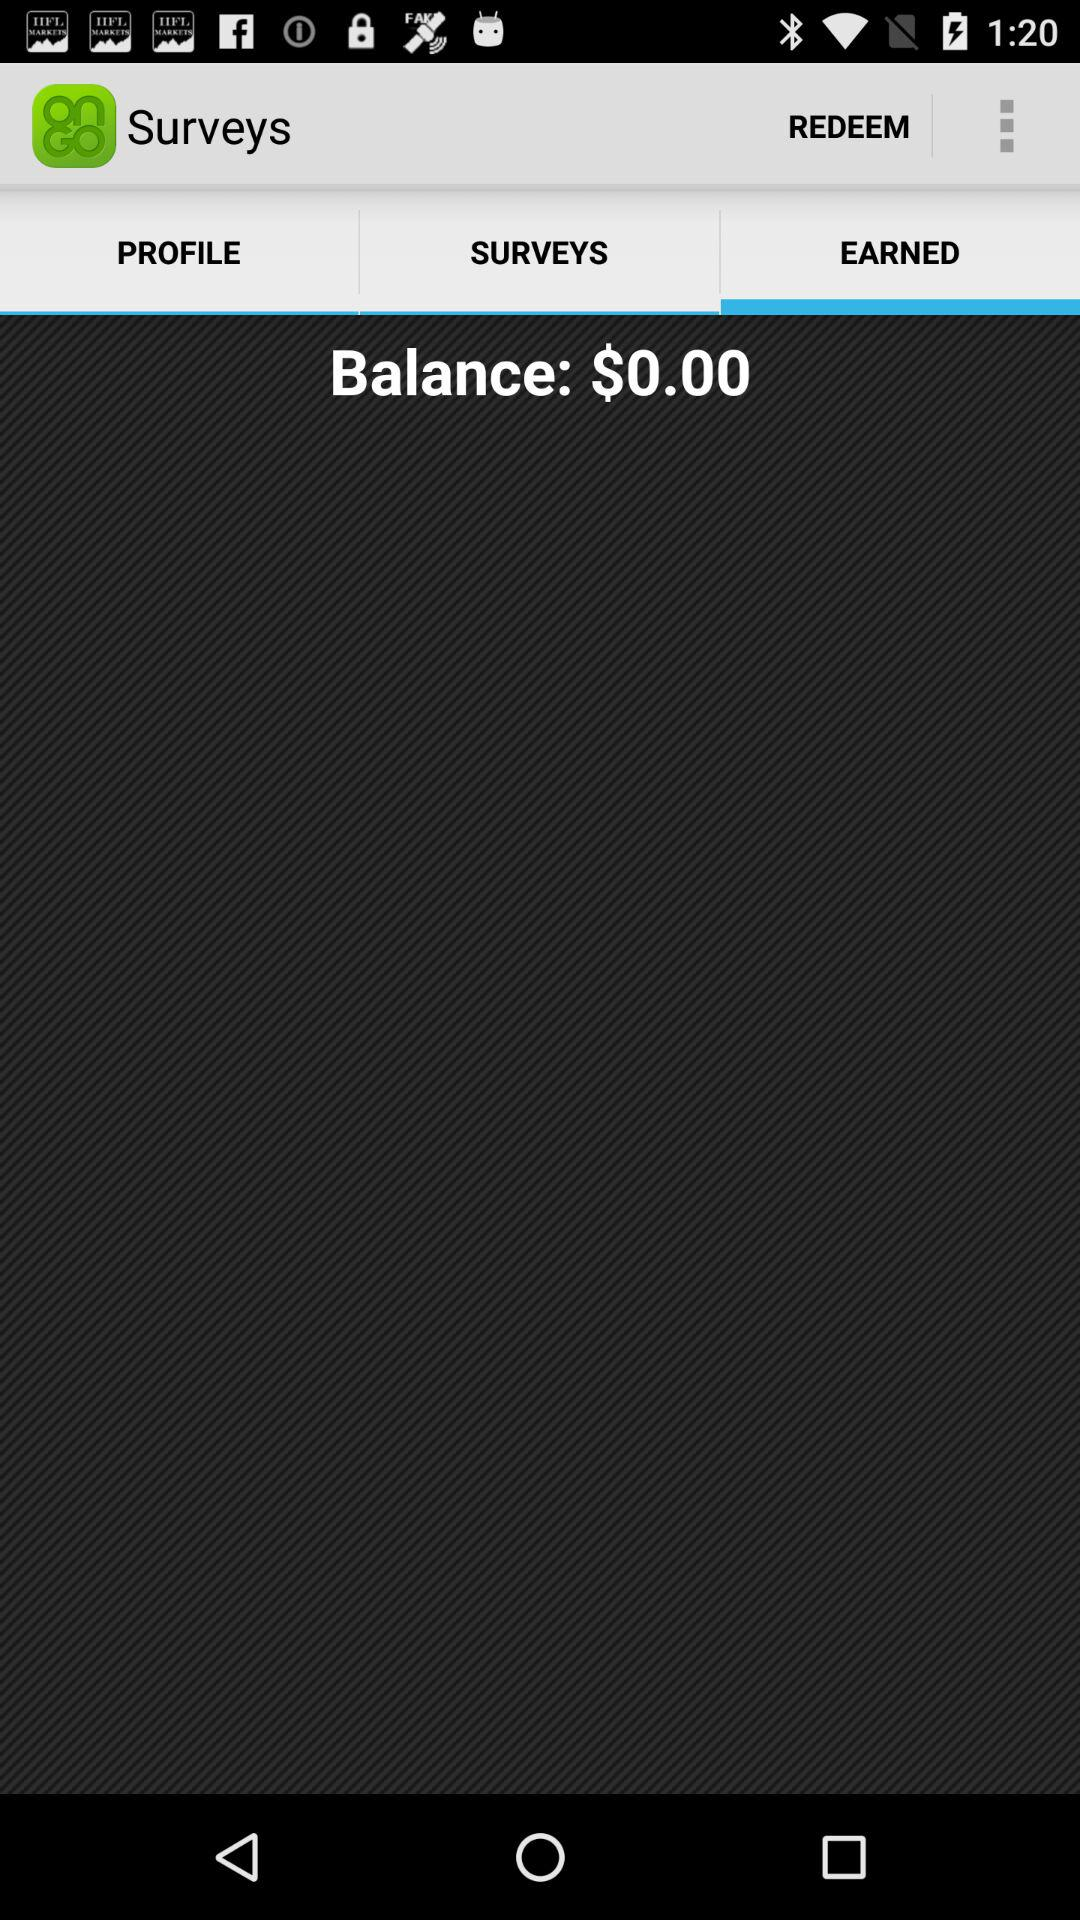What is the balance? The balance is $0.00. 